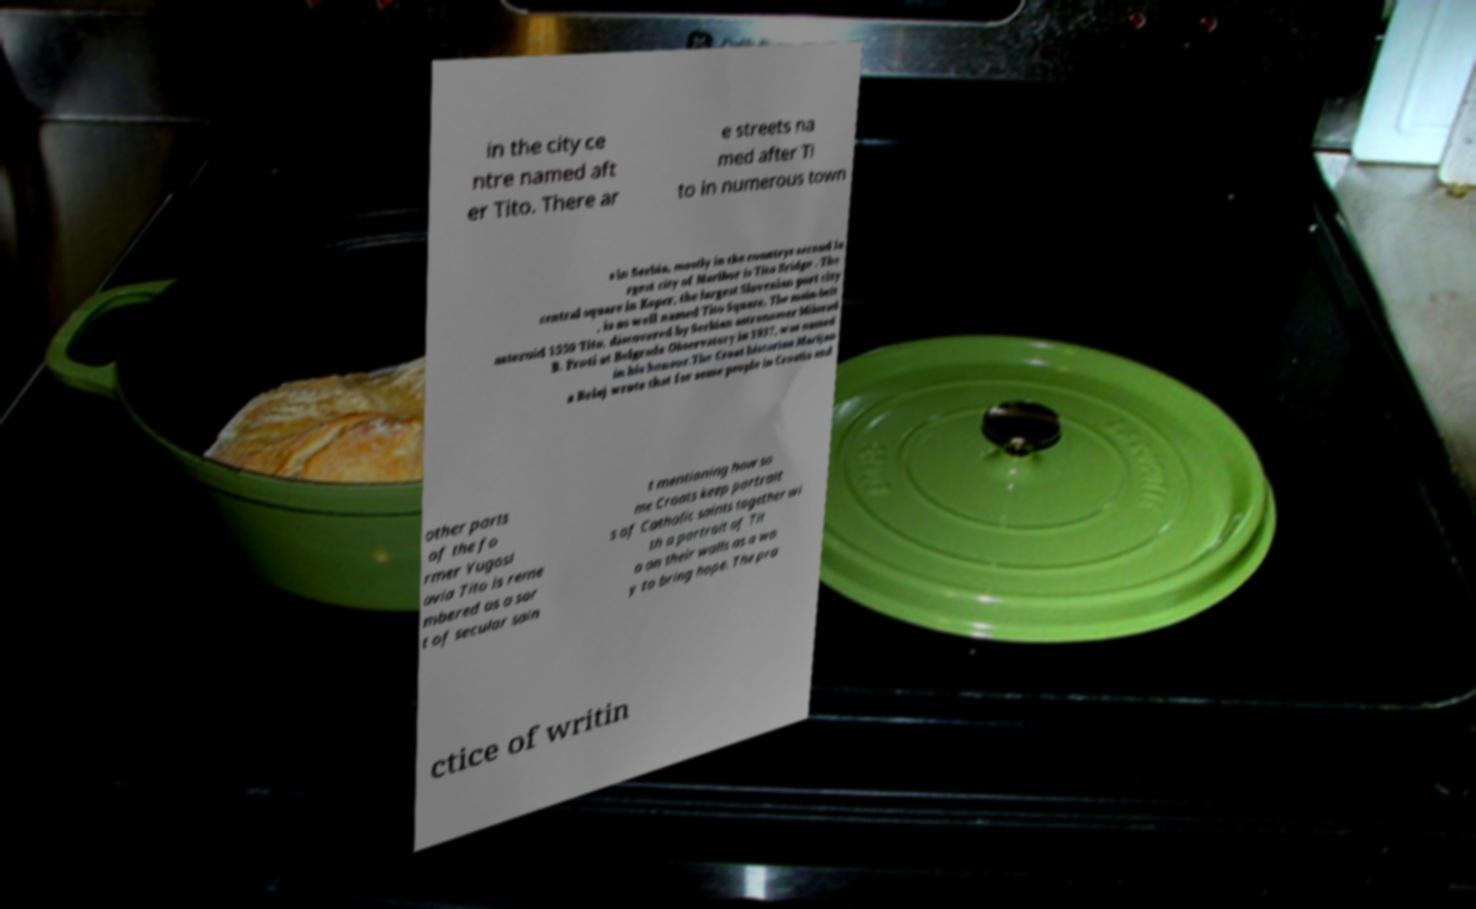Please identify and transcribe the text found in this image. in the city ce ntre named aft er Tito. There ar e streets na med after Ti to in numerous town s in Serbia, mostly in the countrys second la rgest city of Maribor is Tito Bridge . The central square in Koper, the largest Slovenian port city , is as well named Tito Square. The main-belt asteroid 1550 Tito, discovered by Serbian astronomer Milorad B. Proti at Belgrade Observatory in 1937, was named in his honour.The Croat historian Marijan a Belaj wrote that for some people in Croatia and other parts of the fo rmer Yugosl avia Tito is reme mbered as a sor t of secular sain t mentioning how so me Croats keep portrait s of Catholic saints together wi th a portrait of Tit o on their walls as a wa y to bring hope. The pra ctice of writin 